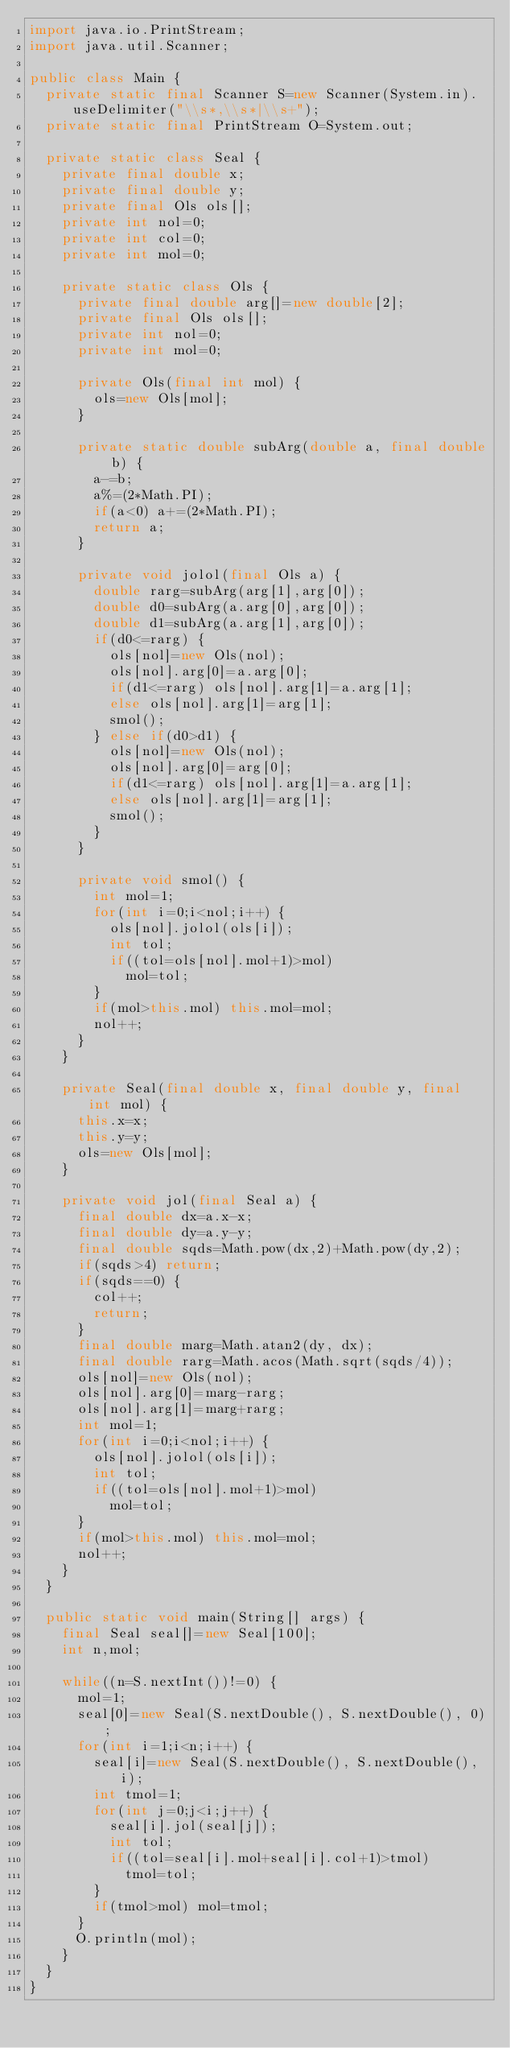<code> <loc_0><loc_0><loc_500><loc_500><_Java_>import java.io.PrintStream;
import java.util.Scanner;

public class Main {
	private static final Scanner S=new Scanner(System.in).useDelimiter("\\s*,\\s*|\\s+");
	private static final PrintStream O=System.out;
	
	private static class Seal {
		private final double x;
		private final double y;
		private final Ols ols[];
		private int nol=0;
		private int col=0;
		private int mol=0;
		
		private static class Ols {
			private final double arg[]=new double[2];
			private final Ols ols[];
			private int nol=0;
			private int mol=0;
			
			private Ols(final int mol) {
				ols=new Ols[mol];
			}
			
			private static double subArg(double a, final double b) {
				a-=b;
				a%=(2*Math.PI);
				if(a<0) a+=(2*Math.PI);
				return a;
			}
			
			private void jolol(final Ols a) {
				double rarg=subArg(arg[1],arg[0]);
				double d0=subArg(a.arg[0],arg[0]);
				double d1=subArg(a.arg[1],arg[0]);
				if(d0<=rarg) {
					ols[nol]=new Ols(nol);
					ols[nol].arg[0]=a.arg[0];
					if(d1<=rarg) ols[nol].arg[1]=a.arg[1];
					else ols[nol].arg[1]=arg[1];
					smol();
				} else if(d0>d1) {
					ols[nol]=new Ols(nol);
					ols[nol].arg[0]=arg[0];
					if(d1<=rarg) ols[nol].arg[1]=a.arg[1];
					else ols[nol].arg[1]=arg[1];
					smol();
				}
			}
			
			private void smol() {
				int mol=1;
				for(int i=0;i<nol;i++) {
					ols[nol].jolol(ols[i]);
					int tol;
					if((tol=ols[nol].mol+1)>mol)
						mol=tol;
				}
				if(mol>this.mol) this.mol=mol;
				nol++;
			}
		}
		
		private Seal(final double x, final double y, final int mol) {
			this.x=x;
			this.y=y;
			ols=new Ols[mol];
		}
		
		private void jol(final Seal a) {
			final double dx=a.x-x;
			final double dy=a.y-y;
			final double sqds=Math.pow(dx,2)+Math.pow(dy,2);
			if(sqds>4) return;
			if(sqds==0) {
				col++;
				return;
			}
			final double marg=Math.atan2(dy, dx);
			final double rarg=Math.acos(Math.sqrt(sqds/4));
			ols[nol]=new Ols(nol);
			ols[nol].arg[0]=marg-rarg;
			ols[nol].arg[1]=marg+rarg;
			int mol=1;
			for(int i=0;i<nol;i++) {
				ols[nol].jolol(ols[i]);
				int tol;
				if((tol=ols[nol].mol+1)>mol)
					mol=tol;
			}
			if(mol>this.mol) this.mol=mol;
			nol++;
		}
	}
	
	public static void main(String[] args) {
		final Seal seal[]=new Seal[100];
		int n,mol;
		
		while((n=S.nextInt())!=0) {
			mol=1;
			seal[0]=new Seal(S.nextDouble(), S.nextDouble(), 0);
			for(int i=1;i<n;i++) {
				seal[i]=new Seal(S.nextDouble(), S.nextDouble(), i);
				int tmol=1;
				for(int j=0;j<i;j++) {
					seal[i].jol(seal[j]);
					int tol;
					if((tol=seal[i].mol+seal[i].col+1)>tmol)
						tmol=tol;
				}
				if(tmol>mol) mol=tmol;
			}
			O.println(mol);
		}
	}
}</code> 